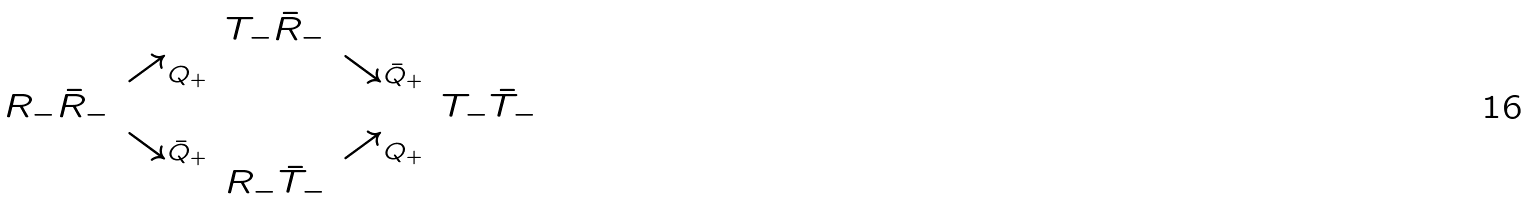Convert formula to latex. <formula><loc_0><loc_0><loc_500><loc_500>\begin{array} { c c c c c } & & T _ { - } \bar { R } _ { - } & & \\ & \nearrow _ { Q _ { + } } & & \searrow _ { \bar { Q } _ { + } } & \\ R _ { - } \bar { R } _ { - } & & & & T _ { - } \bar { T } _ { - } \\ & \searrow _ { \bar { Q } _ { + } } & & \nearrow _ { Q _ { + } } & \\ & & R _ { - } \bar { T } _ { - } & & \end{array}</formula> 